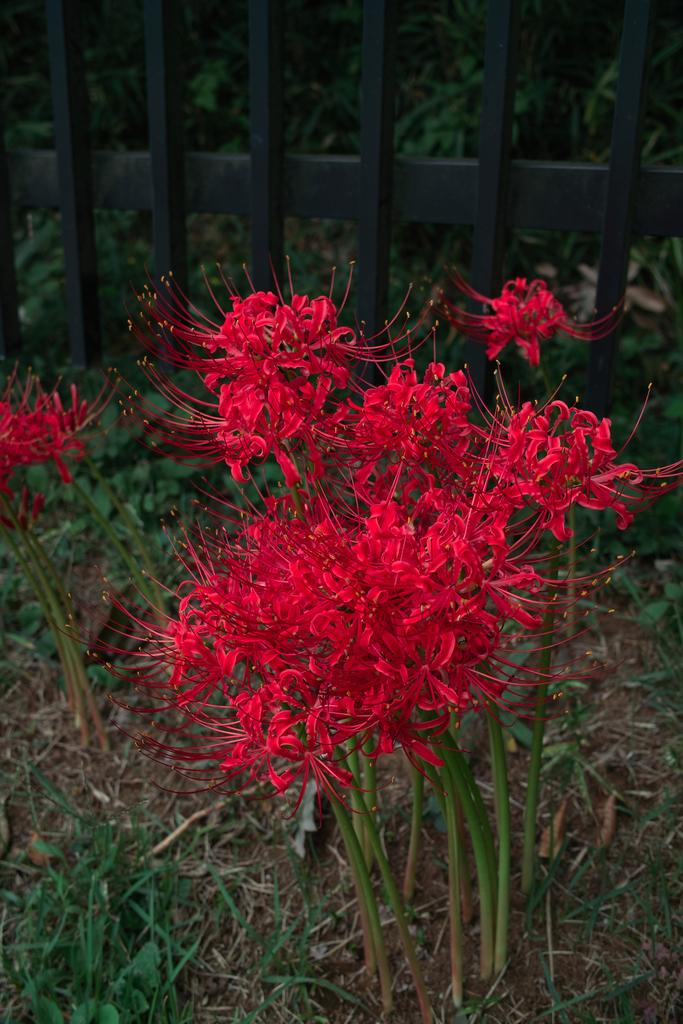What can be seen in the background of the image? There is a black grill and plants in the background of the image. What type of plants are present in the image? There are red flower plants in the image. What type of vegetation is visible in the image? There is grass visible in the image. What type of bread is being toasted on the black grill in the image? There is no bread present in the image, and the black grill is not being used for toasting. 